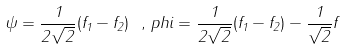<formula> <loc_0><loc_0><loc_500><loc_500>\psi = \frac { 1 } { 2 \sqrt { 2 } } ( f _ { 1 } - f _ { 2 } ) \ , \, p h i = \frac { 1 } { 2 \sqrt { 2 } } ( f _ { 1 } - f _ { 2 } ) - \frac { 1 } { \sqrt { 2 } } f</formula> 